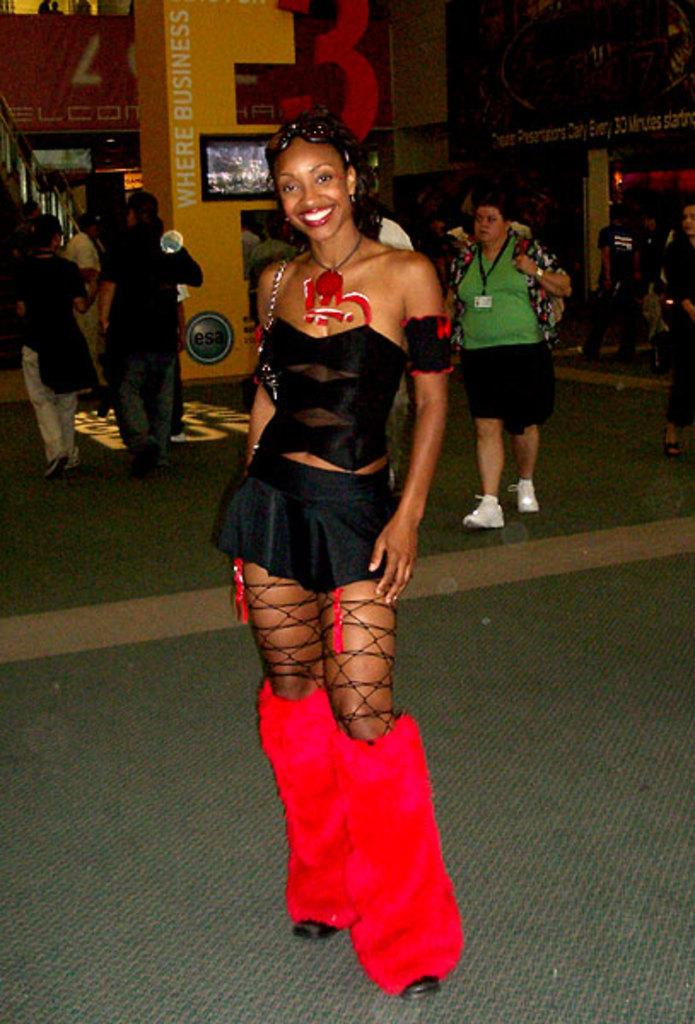What are the people in the image doing? The people in the image are walking on the road. Where is the TV located in the image? The TV is attached to the wall in the image. What can be seen on the left side of the image? There are stairs on the left side of the image. What type of stove is visible in the image? There is no stove present in the image. What are the people talking about while walking on the road? The image does not provide any information about what the people might be talking about. 